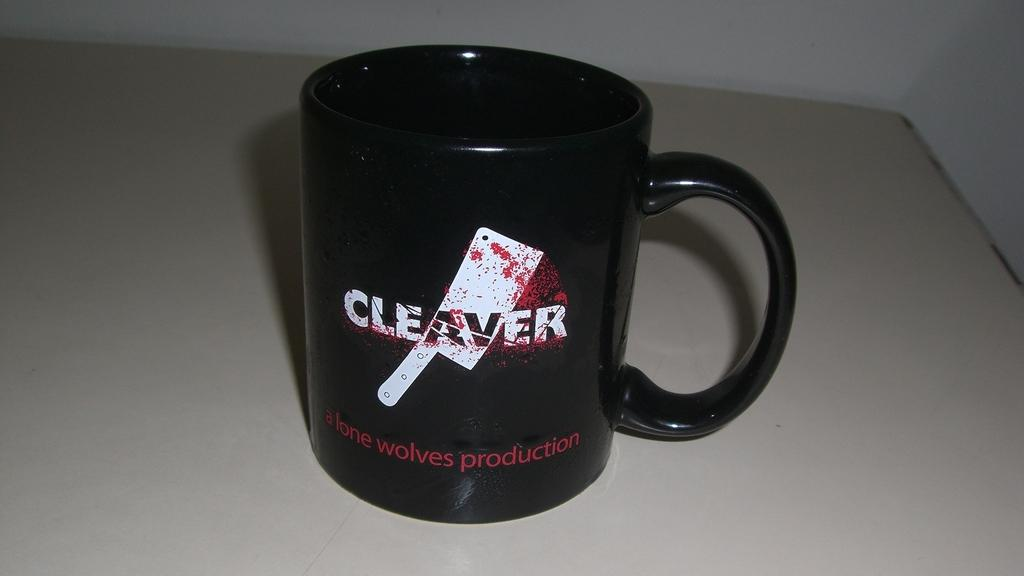<image>
Give a short and clear explanation of the subsequent image. A black coffee mug with the word cleaver on the center of it. 